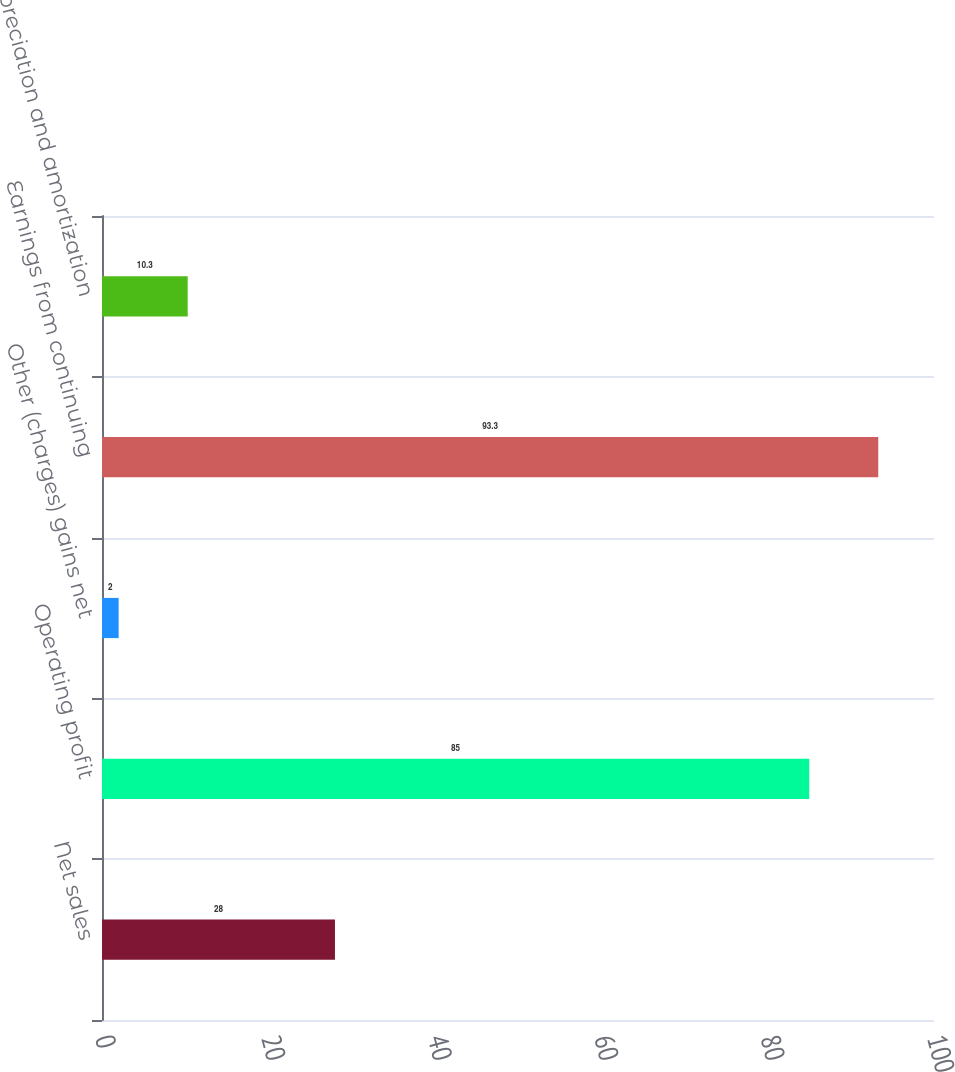Convert chart to OTSL. <chart><loc_0><loc_0><loc_500><loc_500><bar_chart><fcel>Net sales<fcel>Operating profit<fcel>Other (charges) gains net<fcel>Earnings from continuing<fcel>Depreciation and amortization<nl><fcel>28<fcel>85<fcel>2<fcel>93.3<fcel>10.3<nl></chart> 